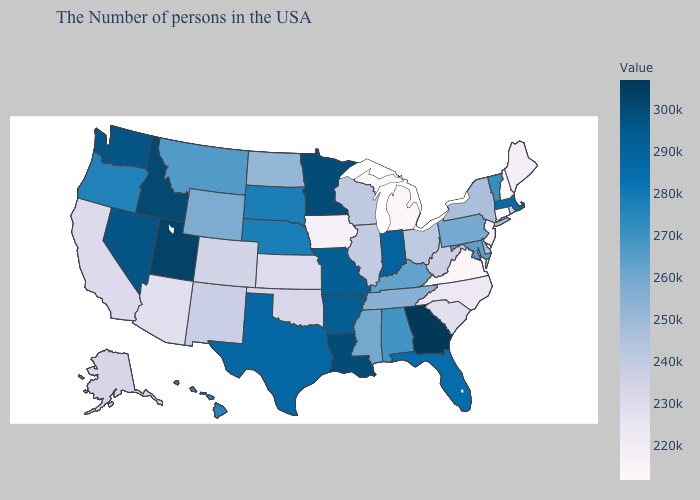Does New Jersey have the highest value in the Northeast?
Short answer required. No. 